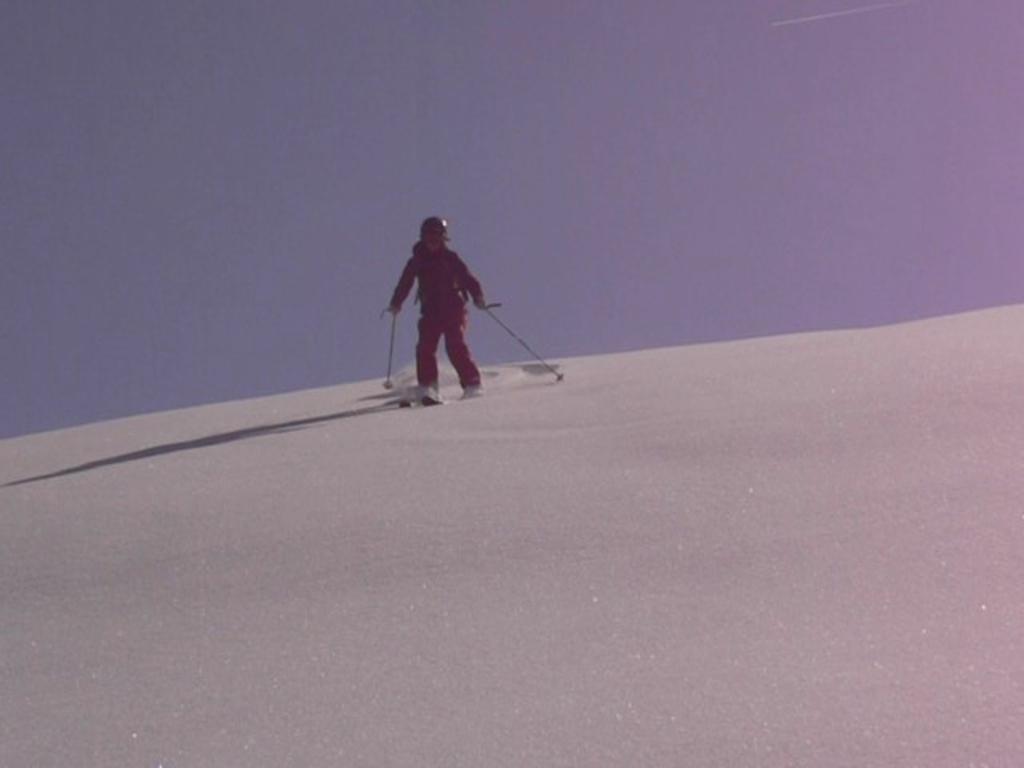Describe this image in one or two sentences. In this image we can see a person is skating on the surface snow and he is wearing red color dress with helmet. 